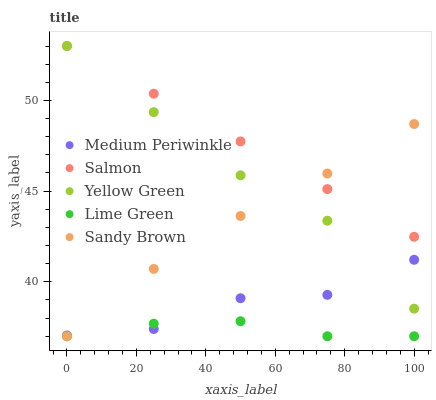Does Lime Green have the minimum area under the curve?
Answer yes or no. Yes. Does Salmon have the maximum area under the curve?
Answer yes or no. Yes. Does Medium Periwinkle have the minimum area under the curve?
Answer yes or no. No. Does Medium Periwinkle have the maximum area under the curve?
Answer yes or no. No. Is Salmon the smoothest?
Answer yes or no. Yes. Is Medium Periwinkle the roughest?
Answer yes or no. Yes. Is Medium Periwinkle the smoothest?
Answer yes or no. No. Is Salmon the roughest?
Answer yes or no. No. Does Sandy Brown have the lowest value?
Answer yes or no. Yes. Does Medium Periwinkle have the lowest value?
Answer yes or no. No. Does Yellow Green have the highest value?
Answer yes or no. Yes. Does Medium Periwinkle have the highest value?
Answer yes or no. No. Is Lime Green less than Yellow Green?
Answer yes or no. Yes. Is Salmon greater than Medium Periwinkle?
Answer yes or no. Yes. Does Medium Periwinkle intersect Lime Green?
Answer yes or no. Yes. Is Medium Periwinkle less than Lime Green?
Answer yes or no. No. Is Medium Periwinkle greater than Lime Green?
Answer yes or no. No. Does Lime Green intersect Yellow Green?
Answer yes or no. No. 